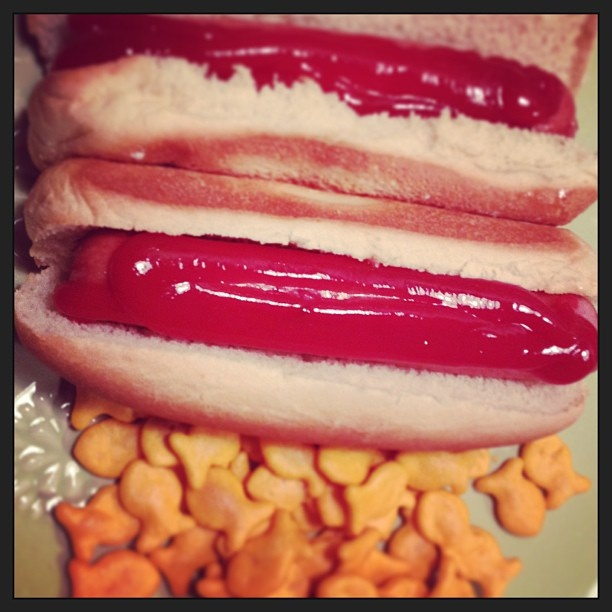Describe the objects in this image and their specific colors. I can see hot dog in black, brown, and tan tones and hot dog in black, brown, tan, and maroon tones in this image. 